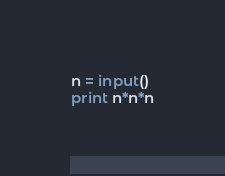Convert code to text. <code><loc_0><loc_0><loc_500><loc_500><_Python_>n = input()
print n*n*n</code> 